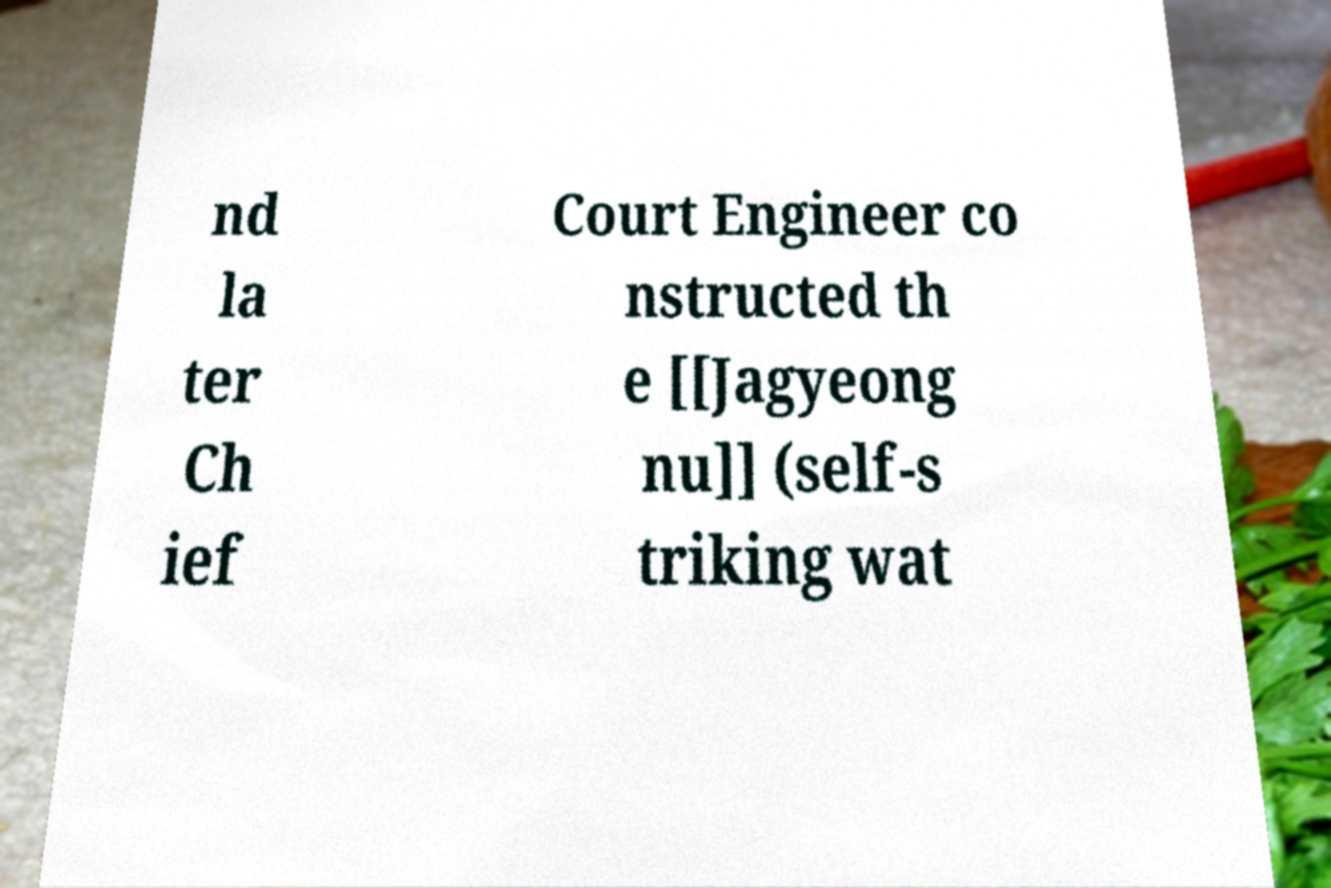I need the written content from this picture converted into text. Can you do that? nd la ter Ch ief Court Engineer co nstructed th e [[Jagyeong nu]] (self-s triking wat 